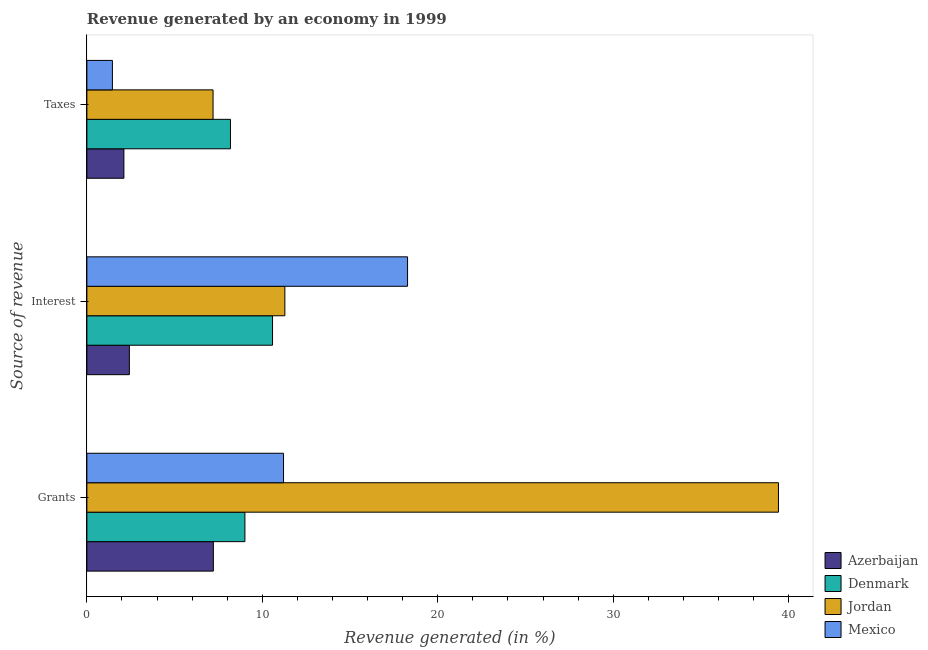How many groups of bars are there?
Make the answer very short. 3. Are the number of bars per tick equal to the number of legend labels?
Ensure brevity in your answer.  Yes. How many bars are there on the 2nd tick from the bottom?
Make the answer very short. 4. What is the label of the 3rd group of bars from the top?
Provide a short and direct response. Grants. What is the percentage of revenue generated by interest in Mexico?
Provide a short and direct response. 18.28. Across all countries, what is the maximum percentage of revenue generated by grants?
Provide a short and direct response. 39.42. Across all countries, what is the minimum percentage of revenue generated by taxes?
Offer a terse response. 1.46. In which country was the percentage of revenue generated by grants maximum?
Make the answer very short. Jordan. In which country was the percentage of revenue generated by grants minimum?
Provide a short and direct response. Azerbaijan. What is the total percentage of revenue generated by grants in the graph?
Ensure brevity in your answer.  66.84. What is the difference between the percentage of revenue generated by taxes in Denmark and that in Azerbaijan?
Your response must be concise. 6.07. What is the difference between the percentage of revenue generated by grants in Jordan and the percentage of revenue generated by interest in Mexico?
Your response must be concise. 21.14. What is the average percentage of revenue generated by interest per country?
Provide a short and direct response. 10.64. What is the difference between the percentage of revenue generated by taxes and percentage of revenue generated by interest in Jordan?
Ensure brevity in your answer.  -4.09. In how many countries, is the percentage of revenue generated by taxes greater than 8 %?
Offer a terse response. 1. What is the ratio of the percentage of revenue generated by grants in Azerbaijan to that in Jordan?
Your answer should be very brief. 0.18. Is the percentage of revenue generated by interest in Denmark less than that in Mexico?
Give a very brief answer. Yes. What is the difference between the highest and the second highest percentage of revenue generated by taxes?
Your answer should be very brief. 0.99. What is the difference between the highest and the lowest percentage of revenue generated by taxes?
Provide a succinct answer. 6.73. What does the 4th bar from the top in Taxes represents?
Provide a short and direct response. Azerbaijan. What does the 4th bar from the bottom in Taxes represents?
Give a very brief answer. Mexico. Is it the case that in every country, the sum of the percentage of revenue generated by grants and percentage of revenue generated by interest is greater than the percentage of revenue generated by taxes?
Your response must be concise. Yes. How many bars are there?
Ensure brevity in your answer.  12. Are the values on the major ticks of X-axis written in scientific E-notation?
Your answer should be very brief. No. Does the graph contain any zero values?
Give a very brief answer. No. Where does the legend appear in the graph?
Make the answer very short. Bottom right. What is the title of the graph?
Offer a very short reply. Revenue generated by an economy in 1999. What is the label or title of the X-axis?
Make the answer very short. Revenue generated (in %). What is the label or title of the Y-axis?
Make the answer very short. Source of revenue. What is the Revenue generated (in %) of Azerbaijan in Grants?
Ensure brevity in your answer.  7.21. What is the Revenue generated (in %) of Denmark in Grants?
Your response must be concise. 9.01. What is the Revenue generated (in %) in Jordan in Grants?
Your response must be concise. 39.42. What is the Revenue generated (in %) in Mexico in Grants?
Provide a succinct answer. 11.21. What is the Revenue generated (in %) in Azerbaijan in Interest?
Give a very brief answer. 2.42. What is the Revenue generated (in %) of Denmark in Interest?
Offer a very short reply. 10.58. What is the Revenue generated (in %) in Jordan in Interest?
Your answer should be compact. 11.28. What is the Revenue generated (in %) of Mexico in Interest?
Your response must be concise. 18.28. What is the Revenue generated (in %) in Azerbaijan in Taxes?
Provide a succinct answer. 2.11. What is the Revenue generated (in %) of Denmark in Taxes?
Your answer should be very brief. 8.18. What is the Revenue generated (in %) in Jordan in Taxes?
Your answer should be very brief. 7.19. What is the Revenue generated (in %) of Mexico in Taxes?
Offer a terse response. 1.46. Across all Source of revenue, what is the maximum Revenue generated (in %) of Azerbaijan?
Offer a very short reply. 7.21. Across all Source of revenue, what is the maximum Revenue generated (in %) in Denmark?
Keep it short and to the point. 10.58. Across all Source of revenue, what is the maximum Revenue generated (in %) of Jordan?
Provide a succinct answer. 39.42. Across all Source of revenue, what is the maximum Revenue generated (in %) of Mexico?
Give a very brief answer. 18.28. Across all Source of revenue, what is the minimum Revenue generated (in %) of Azerbaijan?
Your answer should be very brief. 2.11. Across all Source of revenue, what is the minimum Revenue generated (in %) in Denmark?
Your answer should be very brief. 8.18. Across all Source of revenue, what is the minimum Revenue generated (in %) of Jordan?
Offer a terse response. 7.19. Across all Source of revenue, what is the minimum Revenue generated (in %) in Mexico?
Your response must be concise. 1.46. What is the total Revenue generated (in %) in Azerbaijan in the graph?
Your response must be concise. 11.74. What is the total Revenue generated (in %) in Denmark in the graph?
Make the answer very short. 27.77. What is the total Revenue generated (in %) of Jordan in the graph?
Make the answer very short. 57.89. What is the total Revenue generated (in %) in Mexico in the graph?
Give a very brief answer. 30.94. What is the difference between the Revenue generated (in %) of Azerbaijan in Grants and that in Interest?
Ensure brevity in your answer.  4.79. What is the difference between the Revenue generated (in %) of Denmark in Grants and that in Interest?
Your response must be concise. -1.57. What is the difference between the Revenue generated (in %) of Jordan in Grants and that in Interest?
Offer a terse response. 28.13. What is the difference between the Revenue generated (in %) in Mexico in Grants and that in Interest?
Keep it short and to the point. -7.07. What is the difference between the Revenue generated (in %) of Azerbaijan in Grants and that in Taxes?
Your answer should be very brief. 5.1. What is the difference between the Revenue generated (in %) in Denmark in Grants and that in Taxes?
Offer a very short reply. 0.82. What is the difference between the Revenue generated (in %) of Jordan in Grants and that in Taxes?
Keep it short and to the point. 32.23. What is the difference between the Revenue generated (in %) in Mexico in Grants and that in Taxes?
Offer a terse response. 9.75. What is the difference between the Revenue generated (in %) of Azerbaijan in Interest and that in Taxes?
Make the answer very short. 0.31. What is the difference between the Revenue generated (in %) of Denmark in Interest and that in Taxes?
Offer a terse response. 2.4. What is the difference between the Revenue generated (in %) of Jordan in Interest and that in Taxes?
Make the answer very short. 4.09. What is the difference between the Revenue generated (in %) of Mexico in Interest and that in Taxes?
Offer a very short reply. 16.82. What is the difference between the Revenue generated (in %) of Azerbaijan in Grants and the Revenue generated (in %) of Denmark in Interest?
Provide a succinct answer. -3.37. What is the difference between the Revenue generated (in %) of Azerbaijan in Grants and the Revenue generated (in %) of Jordan in Interest?
Provide a short and direct response. -4.08. What is the difference between the Revenue generated (in %) of Azerbaijan in Grants and the Revenue generated (in %) of Mexico in Interest?
Give a very brief answer. -11.07. What is the difference between the Revenue generated (in %) of Denmark in Grants and the Revenue generated (in %) of Jordan in Interest?
Keep it short and to the point. -2.28. What is the difference between the Revenue generated (in %) of Denmark in Grants and the Revenue generated (in %) of Mexico in Interest?
Provide a short and direct response. -9.27. What is the difference between the Revenue generated (in %) of Jordan in Grants and the Revenue generated (in %) of Mexico in Interest?
Provide a succinct answer. 21.14. What is the difference between the Revenue generated (in %) in Azerbaijan in Grants and the Revenue generated (in %) in Denmark in Taxes?
Ensure brevity in your answer.  -0.97. What is the difference between the Revenue generated (in %) in Azerbaijan in Grants and the Revenue generated (in %) in Jordan in Taxes?
Provide a succinct answer. 0.02. What is the difference between the Revenue generated (in %) in Azerbaijan in Grants and the Revenue generated (in %) in Mexico in Taxes?
Keep it short and to the point. 5.75. What is the difference between the Revenue generated (in %) of Denmark in Grants and the Revenue generated (in %) of Jordan in Taxes?
Ensure brevity in your answer.  1.82. What is the difference between the Revenue generated (in %) of Denmark in Grants and the Revenue generated (in %) of Mexico in Taxes?
Keep it short and to the point. 7.55. What is the difference between the Revenue generated (in %) of Jordan in Grants and the Revenue generated (in %) of Mexico in Taxes?
Give a very brief answer. 37.96. What is the difference between the Revenue generated (in %) in Azerbaijan in Interest and the Revenue generated (in %) in Denmark in Taxes?
Provide a succinct answer. -5.76. What is the difference between the Revenue generated (in %) in Azerbaijan in Interest and the Revenue generated (in %) in Jordan in Taxes?
Your response must be concise. -4.77. What is the difference between the Revenue generated (in %) in Azerbaijan in Interest and the Revenue generated (in %) in Mexico in Taxes?
Offer a very short reply. 0.97. What is the difference between the Revenue generated (in %) of Denmark in Interest and the Revenue generated (in %) of Jordan in Taxes?
Keep it short and to the point. 3.39. What is the difference between the Revenue generated (in %) of Denmark in Interest and the Revenue generated (in %) of Mexico in Taxes?
Your answer should be very brief. 9.13. What is the difference between the Revenue generated (in %) in Jordan in Interest and the Revenue generated (in %) in Mexico in Taxes?
Your response must be concise. 9.83. What is the average Revenue generated (in %) in Azerbaijan per Source of revenue?
Offer a terse response. 3.91. What is the average Revenue generated (in %) in Denmark per Source of revenue?
Your response must be concise. 9.26. What is the average Revenue generated (in %) of Jordan per Source of revenue?
Keep it short and to the point. 19.3. What is the average Revenue generated (in %) in Mexico per Source of revenue?
Offer a terse response. 10.31. What is the difference between the Revenue generated (in %) of Azerbaijan and Revenue generated (in %) of Denmark in Grants?
Your answer should be compact. -1.8. What is the difference between the Revenue generated (in %) of Azerbaijan and Revenue generated (in %) of Jordan in Grants?
Give a very brief answer. -32.21. What is the difference between the Revenue generated (in %) of Azerbaijan and Revenue generated (in %) of Mexico in Grants?
Offer a terse response. -4. What is the difference between the Revenue generated (in %) in Denmark and Revenue generated (in %) in Jordan in Grants?
Provide a short and direct response. -30.41. What is the difference between the Revenue generated (in %) of Denmark and Revenue generated (in %) of Mexico in Grants?
Provide a short and direct response. -2.2. What is the difference between the Revenue generated (in %) in Jordan and Revenue generated (in %) in Mexico in Grants?
Provide a short and direct response. 28.21. What is the difference between the Revenue generated (in %) in Azerbaijan and Revenue generated (in %) in Denmark in Interest?
Provide a short and direct response. -8.16. What is the difference between the Revenue generated (in %) of Azerbaijan and Revenue generated (in %) of Jordan in Interest?
Offer a terse response. -8.86. What is the difference between the Revenue generated (in %) in Azerbaijan and Revenue generated (in %) in Mexico in Interest?
Your answer should be very brief. -15.86. What is the difference between the Revenue generated (in %) of Denmark and Revenue generated (in %) of Jordan in Interest?
Offer a very short reply. -0.7. What is the difference between the Revenue generated (in %) in Denmark and Revenue generated (in %) in Mexico in Interest?
Provide a succinct answer. -7.7. What is the difference between the Revenue generated (in %) in Jordan and Revenue generated (in %) in Mexico in Interest?
Give a very brief answer. -6.99. What is the difference between the Revenue generated (in %) of Azerbaijan and Revenue generated (in %) of Denmark in Taxes?
Make the answer very short. -6.07. What is the difference between the Revenue generated (in %) of Azerbaijan and Revenue generated (in %) of Jordan in Taxes?
Provide a succinct answer. -5.08. What is the difference between the Revenue generated (in %) of Azerbaijan and Revenue generated (in %) of Mexico in Taxes?
Offer a terse response. 0.65. What is the difference between the Revenue generated (in %) in Denmark and Revenue generated (in %) in Jordan in Taxes?
Your answer should be compact. 0.99. What is the difference between the Revenue generated (in %) in Denmark and Revenue generated (in %) in Mexico in Taxes?
Your answer should be compact. 6.73. What is the difference between the Revenue generated (in %) of Jordan and Revenue generated (in %) of Mexico in Taxes?
Your answer should be very brief. 5.74. What is the ratio of the Revenue generated (in %) in Azerbaijan in Grants to that in Interest?
Your response must be concise. 2.98. What is the ratio of the Revenue generated (in %) of Denmark in Grants to that in Interest?
Provide a short and direct response. 0.85. What is the ratio of the Revenue generated (in %) of Jordan in Grants to that in Interest?
Your response must be concise. 3.49. What is the ratio of the Revenue generated (in %) in Mexico in Grants to that in Interest?
Your response must be concise. 0.61. What is the ratio of the Revenue generated (in %) in Azerbaijan in Grants to that in Taxes?
Your answer should be very brief. 3.42. What is the ratio of the Revenue generated (in %) in Denmark in Grants to that in Taxes?
Your answer should be compact. 1.1. What is the ratio of the Revenue generated (in %) in Jordan in Grants to that in Taxes?
Offer a very short reply. 5.48. What is the ratio of the Revenue generated (in %) of Mexico in Grants to that in Taxes?
Keep it short and to the point. 7.7. What is the ratio of the Revenue generated (in %) in Azerbaijan in Interest to that in Taxes?
Ensure brevity in your answer.  1.15. What is the ratio of the Revenue generated (in %) in Denmark in Interest to that in Taxes?
Keep it short and to the point. 1.29. What is the ratio of the Revenue generated (in %) in Jordan in Interest to that in Taxes?
Offer a terse response. 1.57. What is the ratio of the Revenue generated (in %) of Mexico in Interest to that in Taxes?
Your answer should be very brief. 12.56. What is the difference between the highest and the second highest Revenue generated (in %) in Azerbaijan?
Your answer should be very brief. 4.79. What is the difference between the highest and the second highest Revenue generated (in %) in Denmark?
Your answer should be compact. 1.57. What is the difference between the highest and the second highest Revenue generated (in %) in Jordan?
Keep it short and to the point. 28.13. What is the difference between the highest and the second highest Revenue generated (in %) of Mexico?
Offer a very short reply. 7.07. What is the difference between the highest and the lowest Revenue generated (in %) of Azerbaijan?
Your response must be concise. 5.1. What is the difference between the highest and the lowest Revenue generated (in %) of Denmark?
Your response must be concise. 2.4. What is the difference between the highest and the lowest Revenue generated (in %) in Jordan?
Offer a terse response. 32.23. What is the difference between the highest and the lowest Revenue generated (in %) in Mexico?
Make the answer very short. 16.82. 